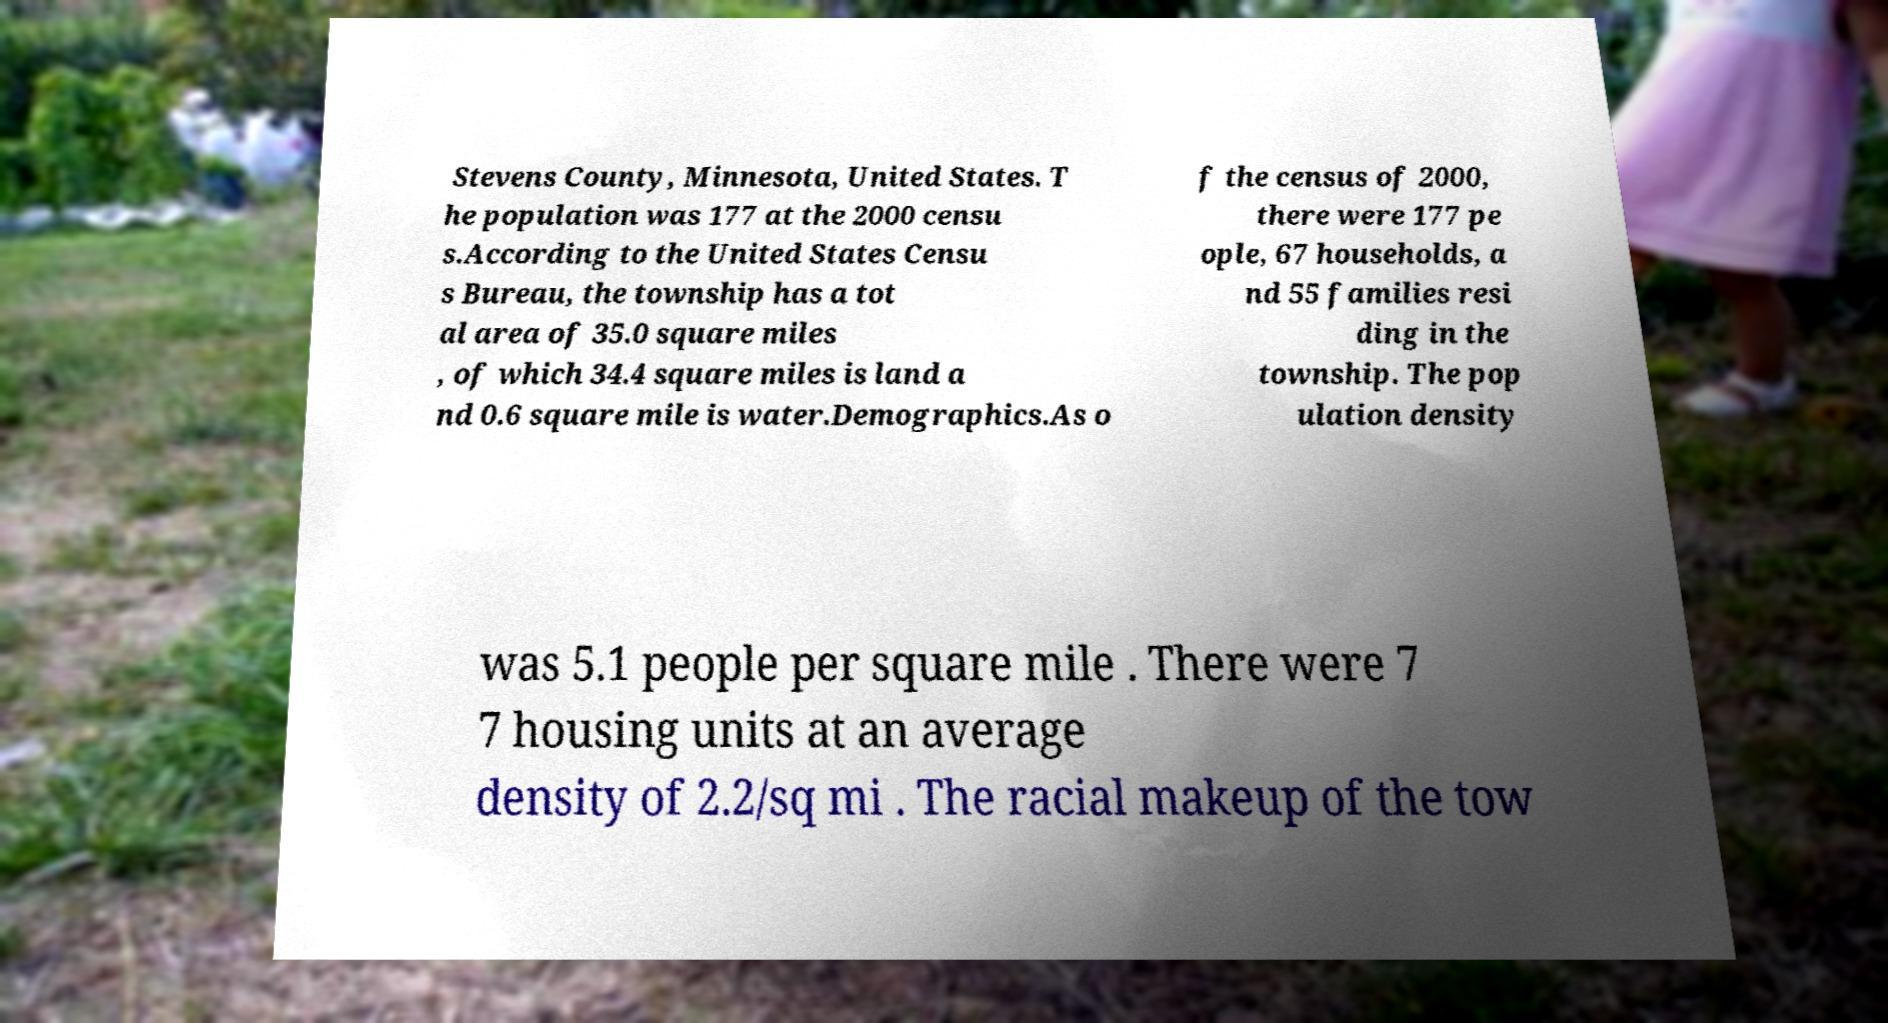I need the written content from this picture converted into text. Can you do that? Stevens County, Minnesota, United States. T he population was 177 at the 2000 censu s.According to the United States Censu s Bureau, the township has a tot al area of 35.0 square miles , of which 34.4 square miles is land a nd 0.6 square mile is water.Demographics.As o f the census of 2000, there were 177 pe ople, 67 households, a nd 55 families resi ding in the township. The pop ulation density was 5.1 people per square mile . There were 7 7 housing units at an average density of 2.2/sq mi . The racial makeup of the tow 